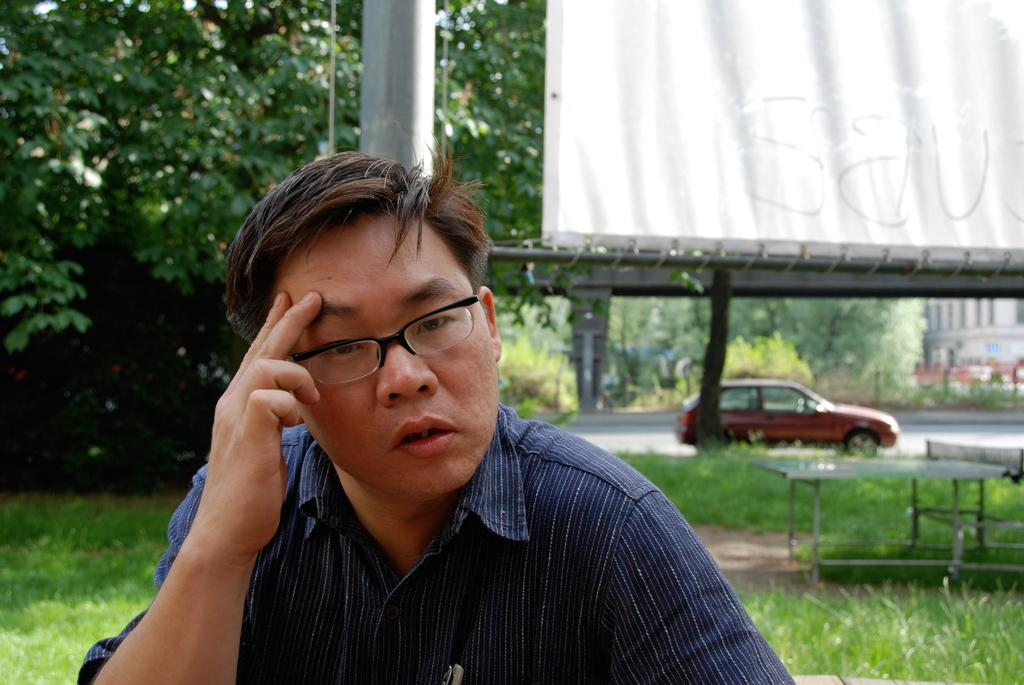What can be seen in the image? There is a person in the image. Can you describe the person's appearance? The person is wearing a shirt and glasses. What is the person doing in the image? The person is looking at something. What can be seen in the background of the image? There is grass, trees, a table, a vehicle on the road, a pole, and cloth visible in the background. How many objects can be seen in the background? There are at least seven objects visible in the background: grass, trees, a table, a vehicle on the road, a pole, and cloth. What type of cord is being used to mine the details in the image? There is no mention of mining or cords in the image. The image features a person looking at something with various objects in the background. 